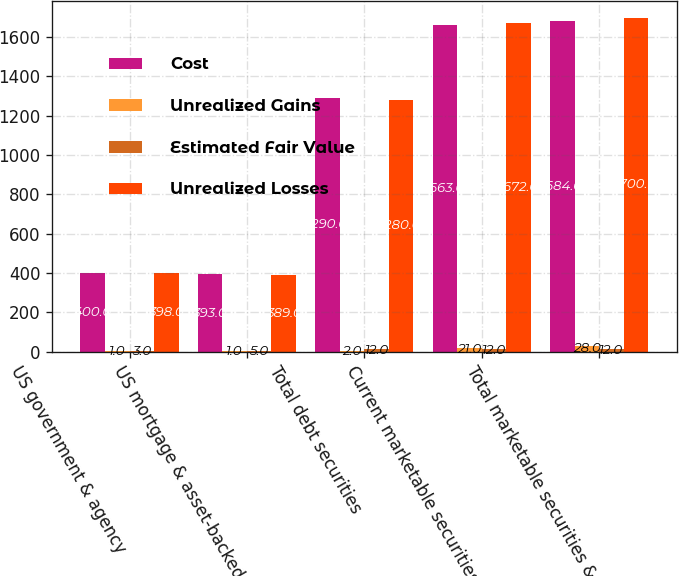Convert chart. <chart><loc_0><loc_0><loc_500><loc_500><stacked_bar_chart><ecel><fcel>US government & agency<fcel>US mortgage & asset-backed<fcel>Total debt securities<fcel>Current marketable securities<fcel>Total marketable securities &<nl><fcel>Cost<fcel>400<fcel>393<fcel>1290<fcel>1663<fcel>1684<nl><fcel>Unrealized Gains<fcel>1<fcel>1<fcel>2<fcel>21<fcel>28<nl><fcel>Estimated Fair Value<fcel>3<fcel>5<fcel>12<fcel>12<fcel>12<nl><fcel>Unrealized Losses<fcel>398<fcel>389<fcel>1280<fcel>1672<fcel>1700<nl></chart> 